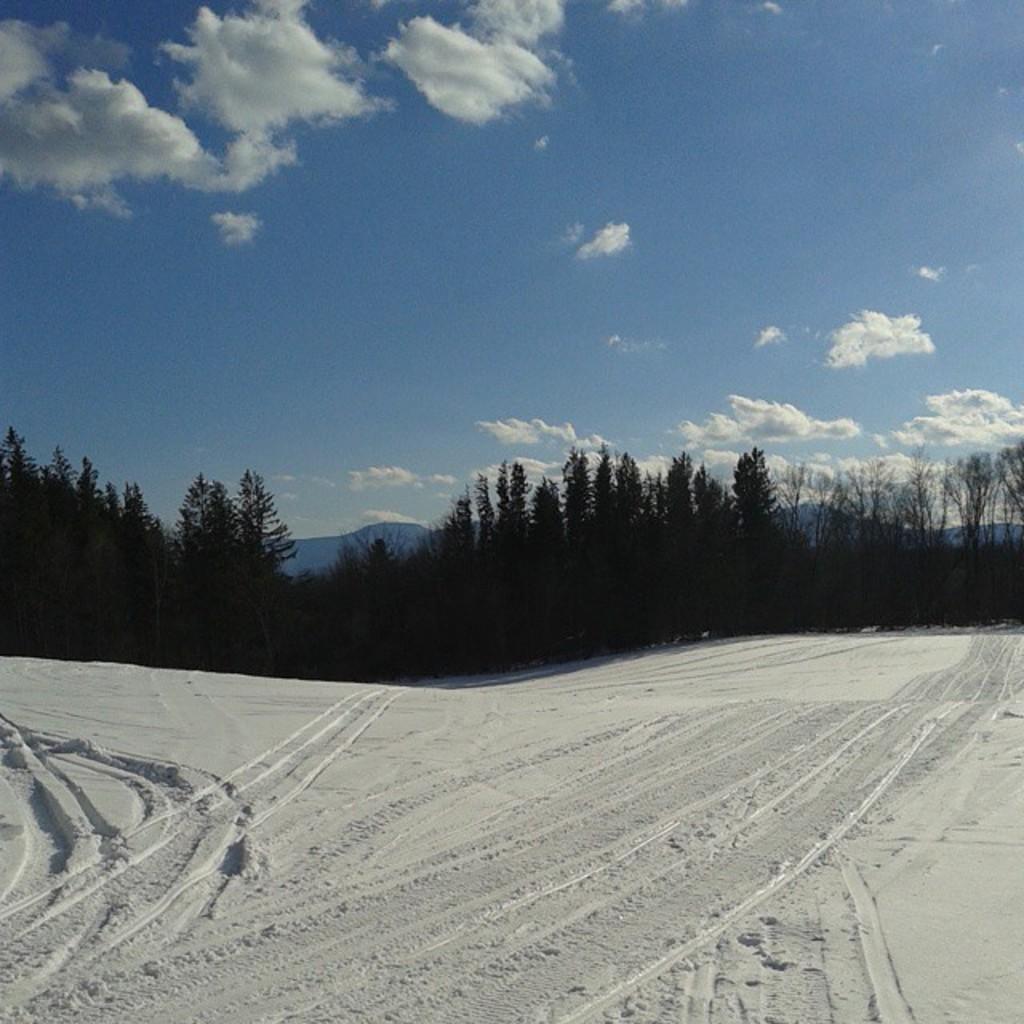In one or two sentences, can you explain what this image depicts? This image is taken outdoors. At the top of the image there is a sky with clouds. At the bottom of the image there is a ground covered with snow. In the middle of the image there are many trees and plants. 